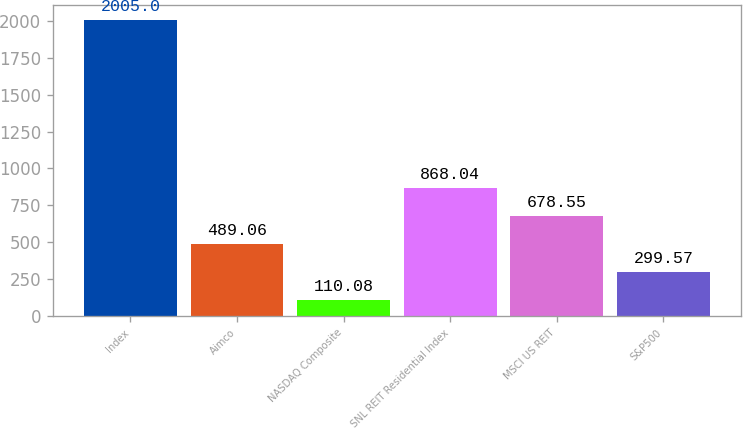<chart> <loc_0><loc_0><loc_500><loc_500><bar_chart><fcel>Index<fcel>Aimco<fcel>NASDAQ Composite<fcel>SNL REIT Residential Index<fcel>MSCI US REIT<fcel>S&P500<nl><fcel>2005<fcel>489.06<fcel>110.08<fcel>868.04<fcel>678.55<fcel>299.57<nl></chart> 